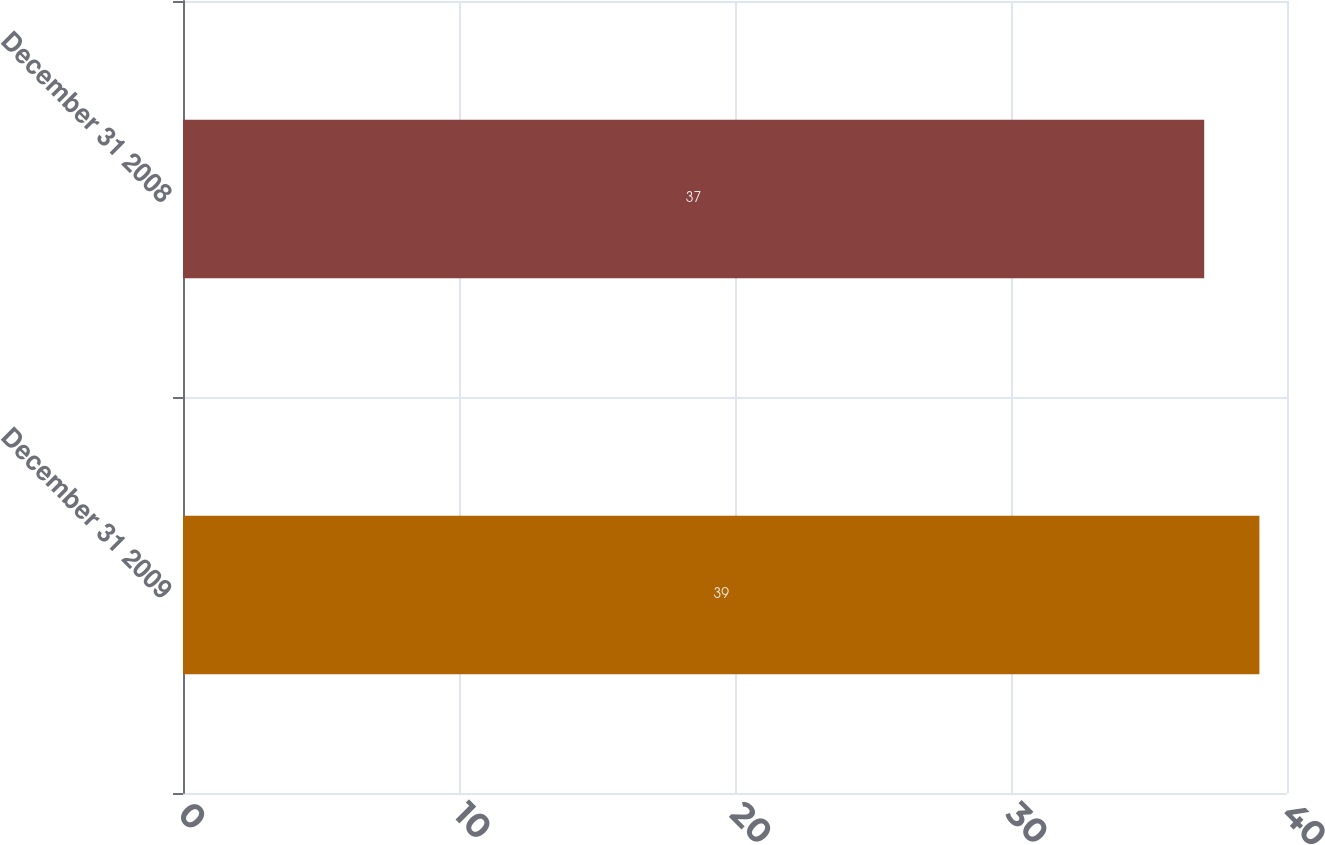Convert chart to OTSL. <chart><loc_0><loc_0><loc_500><loc_500><bar_chart><fcel>December 31 2009<fcel>December 31 2008<nl><fcel>39<fcel>37<nl></chart> 